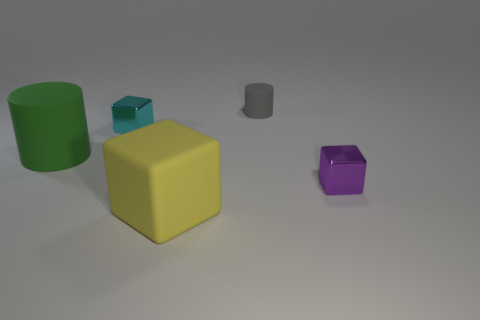Subtract all purple cubes. Subtract all red cylinders. How many cubes are left? 2 Add 2 yellow blocks. How many objects exist? 7 Subtract all cubes. How many objects are left? 2 Add 3 small objects. How many small objects exist? 6 Subtract 1 purple blocks. How many objects are left? 4 Subtract all big yellow blocks. Subtract all yellow objects. How many objects are left? 3 Add 2 large green rubber cylinders. How many large green rubber cylinders are left? 3 